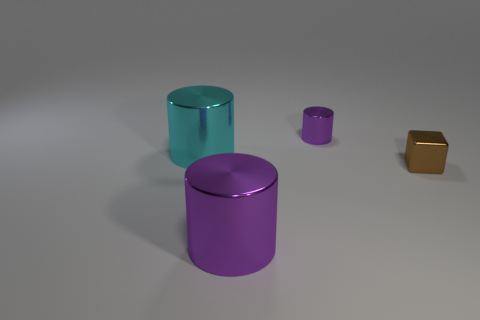Subtract all cyan cylinders. How many cylinders are left? 2 Subtract all cylinders. How many objects are left? 1 Add 2 cylinders. How many objects exist? 6 Subtract all cyan cylinders. How many cylinders are left? 2 Subtract 3 cylinders. How many cylinders are left? 0 Subtract all green cylinders. Subtract all blue cubes. How many cylinders are left? 3 Subtract all red spheres. How many purple cylinders are left? 2 Subtract all small gray cylinders. Subtract all purple metallic cylinders. How many objects are left? 2 Add 4 cyan objects. How many cyan objects are left? 5 Add 3 large objects. How many large objects exist? 5 